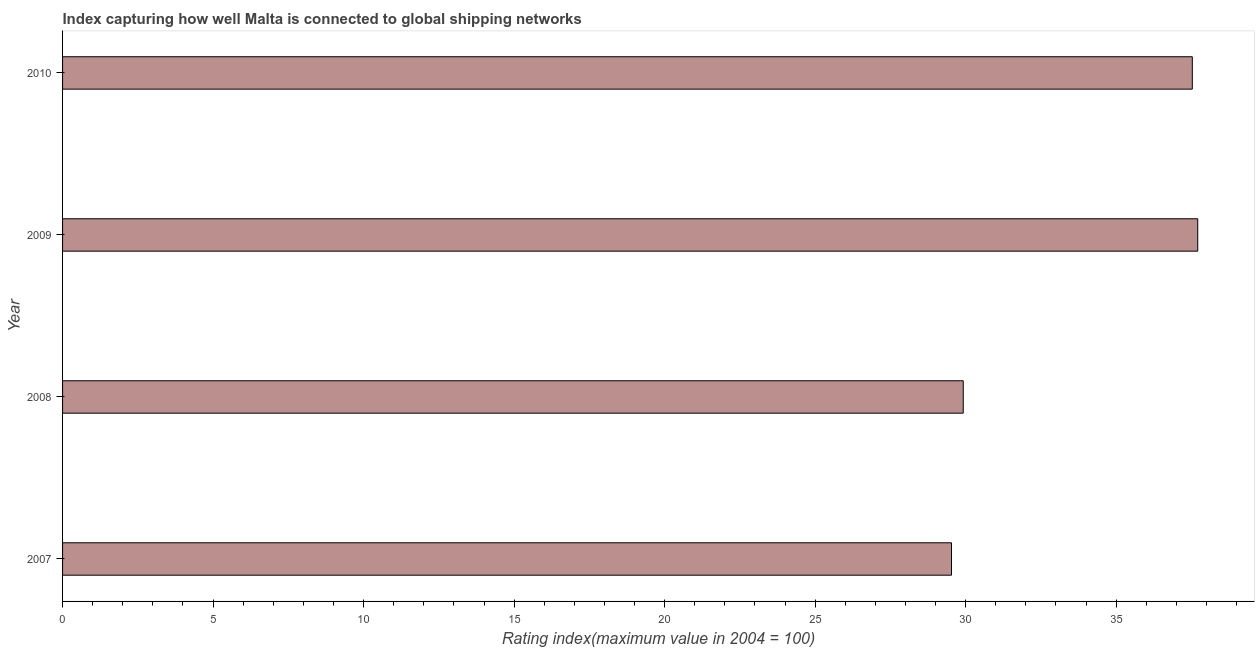What is the title of the graph?
Provide a succinct answer. Index capturing how well Malta is connected to global shipping networks. What is the label or title of the X-axis?
Provide a succinct answer. Rating index(maximum value in 2004 = 100). What is the liner shipping connectivity index in 2007?
Offer a very short reply. 29.53. Across all years, what is the maximum liner shipping connectivity index?
Give a very brief answer. 37.71. Across all years, what is the minimum liner shipping connectivity index?
Provide a short and direct response. 29.53. In which year was the liner shipping connectivity index maximum?
Provide a short and direct response. 2009. What is the sum of the liner shipping connectivity index?
Your answer should be very brief. 134.69. What is the difference between the liner shipping connectivity index in 2007 and 2008?
Ensure brevity in your answer.  -0.39. What is the average liner shipping connectivity index per year?
Offer a very short reply. 33.67. What is the median liner shipping connectivity index?
Give a very brief answer. 33.73. What is the ratio of the liner shipping connectivity index in 2007 to that in 2009?
Keep it short and to the point. 0.78. Is the liner shipping connectivity index in 2009 less than that in 2010?
Give a very brief answer. No. What is the difference between the highest and the second highest liner shipping connectivity index?
Keep it short and to the point. 0.18. What is the difference between the highest and the lowest liner shipping connectivity index?
Give a very brief answer. 8.18. In how many years, is the liner shipping connectivity index greater than the average liner shipping connectivity index taken over all years?
Your answer should be very brief. 2. Are all the bars in the graph horizontal?
Provide a succinct answer. Yes. How many years are there in the graph?
Your answer should be compact. 4. What is the difference between two consecutive major ticks on the X-axis?
Give a very brief answer. 5. Are the values on the major ticks of X-axis written in scientific E-notation?
Your answer should be very brief. No. What is the Rating index(maximum value in 2004 = 100) of 2007?
Offer a very short reply. 29.53. What is the Rating index(maximum value in 2004 = 100) in 2008?
Your answer should be very brief. 29.92. What is the Rating index(maximum value in 2004 = 100) in 2009?
Your response must be concise. 37.71. What is the Rating index(maximum value in 2004 = 100) in 2010?
Your response must be concise. 37.53. What is the difference between the Rating index(maximum value in 2004 = 100) in 2007 and 2008?
Provide a short and direct response. -0.39. What is the difference between the Rating index(maximum value in 2004 = 100) in 2007 and 2009?
Give a very brief answer. -8.18. What is the difference between the Rating index(maximum value in 2004 = 100) in 2008 and 2009?
Make the answer very short. -7.79. What is the difference between the Rating index(maximum value in 2004 = 100) in 2008 and 2010?
Offer a terse response. -7.61. What is the difference between the Rating index(maximum value in 2004 = 100) in 2009 and 2010?
Give a very brief answer. 0.18. What is the ratio of the Rating index(maximum value in 2004 = 100) in 2007 to that in 2008?
Provide a succinct answer. 0.99. What is the ratio of the Rating index(maximum value in 2004 = 100) in 2007 to that in 2009?
Your response must be concise. 0.78. What is the ratio of the Rating index(maximum value in 2004 = 100) in 2007 to that in 2010?
Make the answer very short. 0.79. What is the ratio of the Rating index(maximum value in 2004 = 100) in 2008 to that in 2009?
Offer a terse response. 0.79. What is the ratio of the Rating index(maximum value in 2004 = 100) in 2008 to that in 2010?
Give a very brief answer. 0.8. 